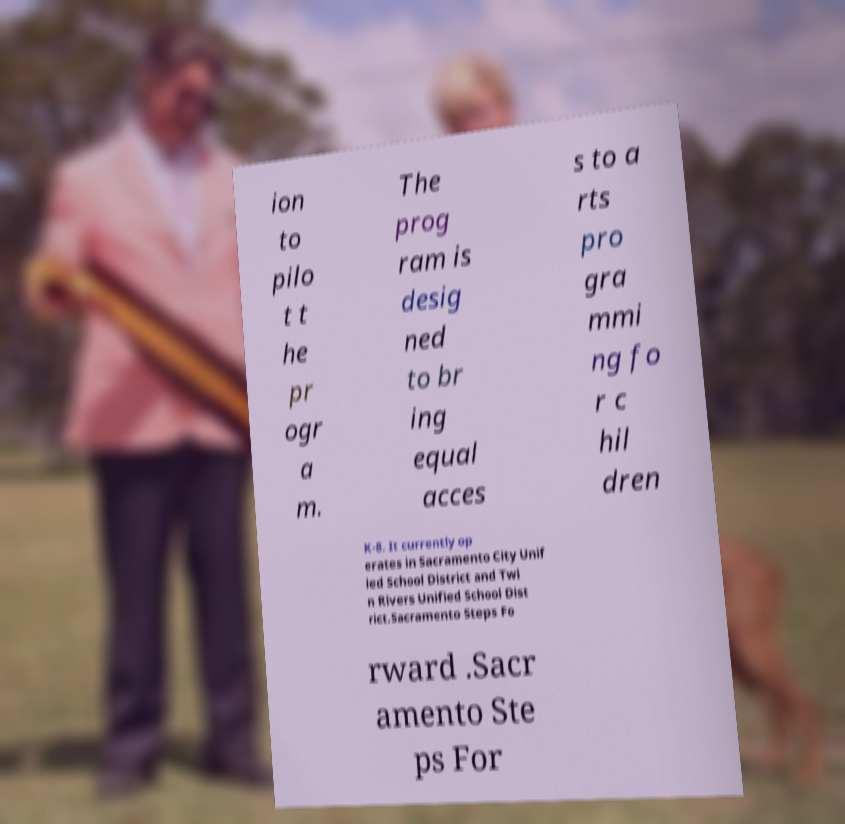Please read and relay the text visible in this image. What does it say? ion to pilo t t he pr ogr a m. The prog ram is desig ned to br ing equal acces s to a rts pro gra mmi ng fo r c hil dren K-8. It currently op erates in Sacramento City Unif ied School District and Twi n Rivers Unified School Dist rict.Sacramento Steps Fo rward .Sacr amento Ste ps For 